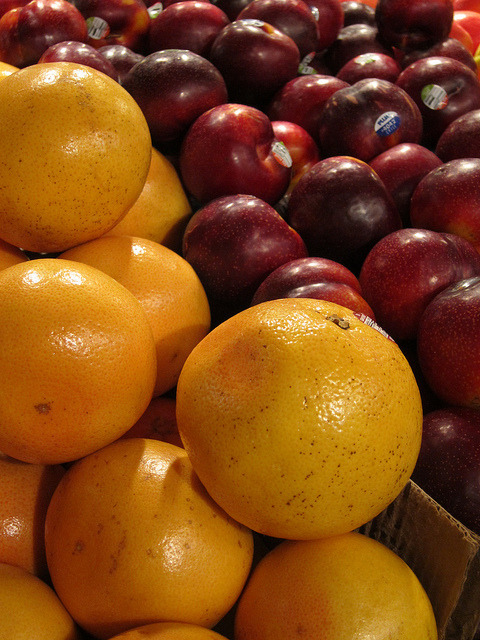How many cherries are there? In this image, there are no cherries present. We can see a collection of oranges and plums. 